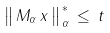Convert formula to latex. <formula><loc_0><loc_0><loc_500><loc_500>\, \left \| { \, M _ { \alpha } \, x \, } \right \| _ { \, \alpha } ^ { \, \ast } \, \leq \, t</formula> 